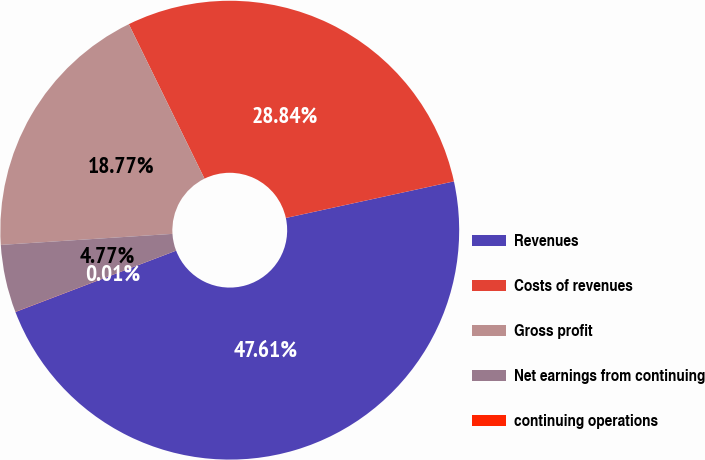Convert chart. <chart><loc_0><loc_0><loc_500><loc_500><pie_chart><fcel>Revenues<fcel>Costs of revenues<fcel>Gross profit<fcel>Net earnings from continuing<fcel>continuing operations<nl><fcel>47.61%<fcel>28.84%<fcel>18.77%<fcel>4.77%<fcel>0.01%<nl></chart> 